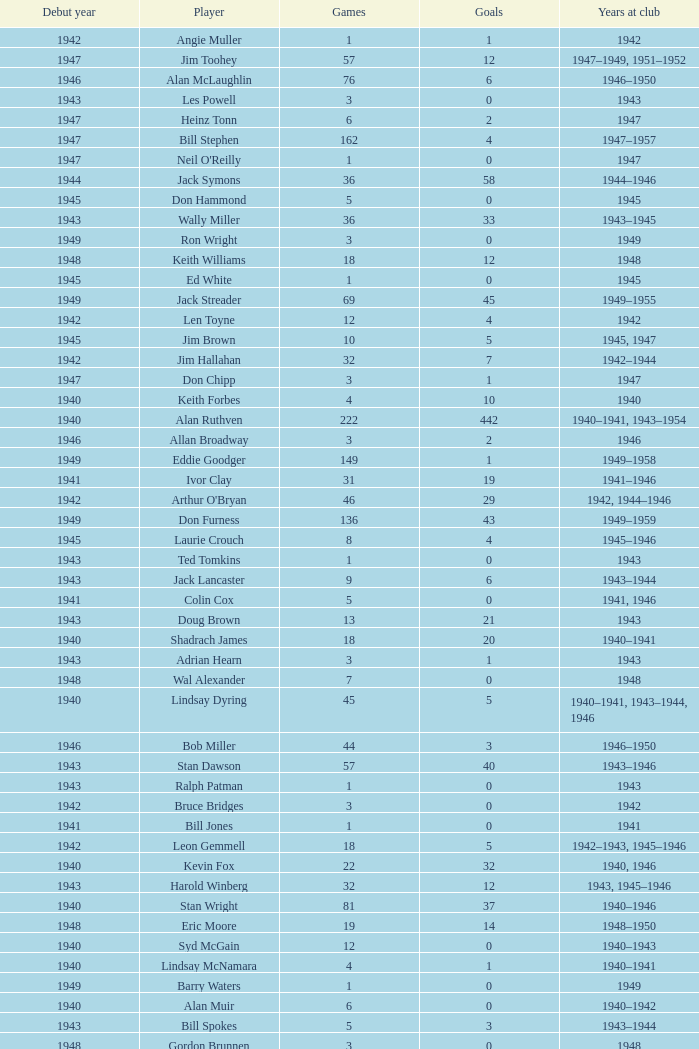Which player debuted before 1943, played for the club in 1942, played less than 12 games, and scored less than 11 goals? Bruce Bridges, George Watson, Reg Hammond, Angie Muller, Leo Hicks, Bernie McVeigh, Billy Hall. 